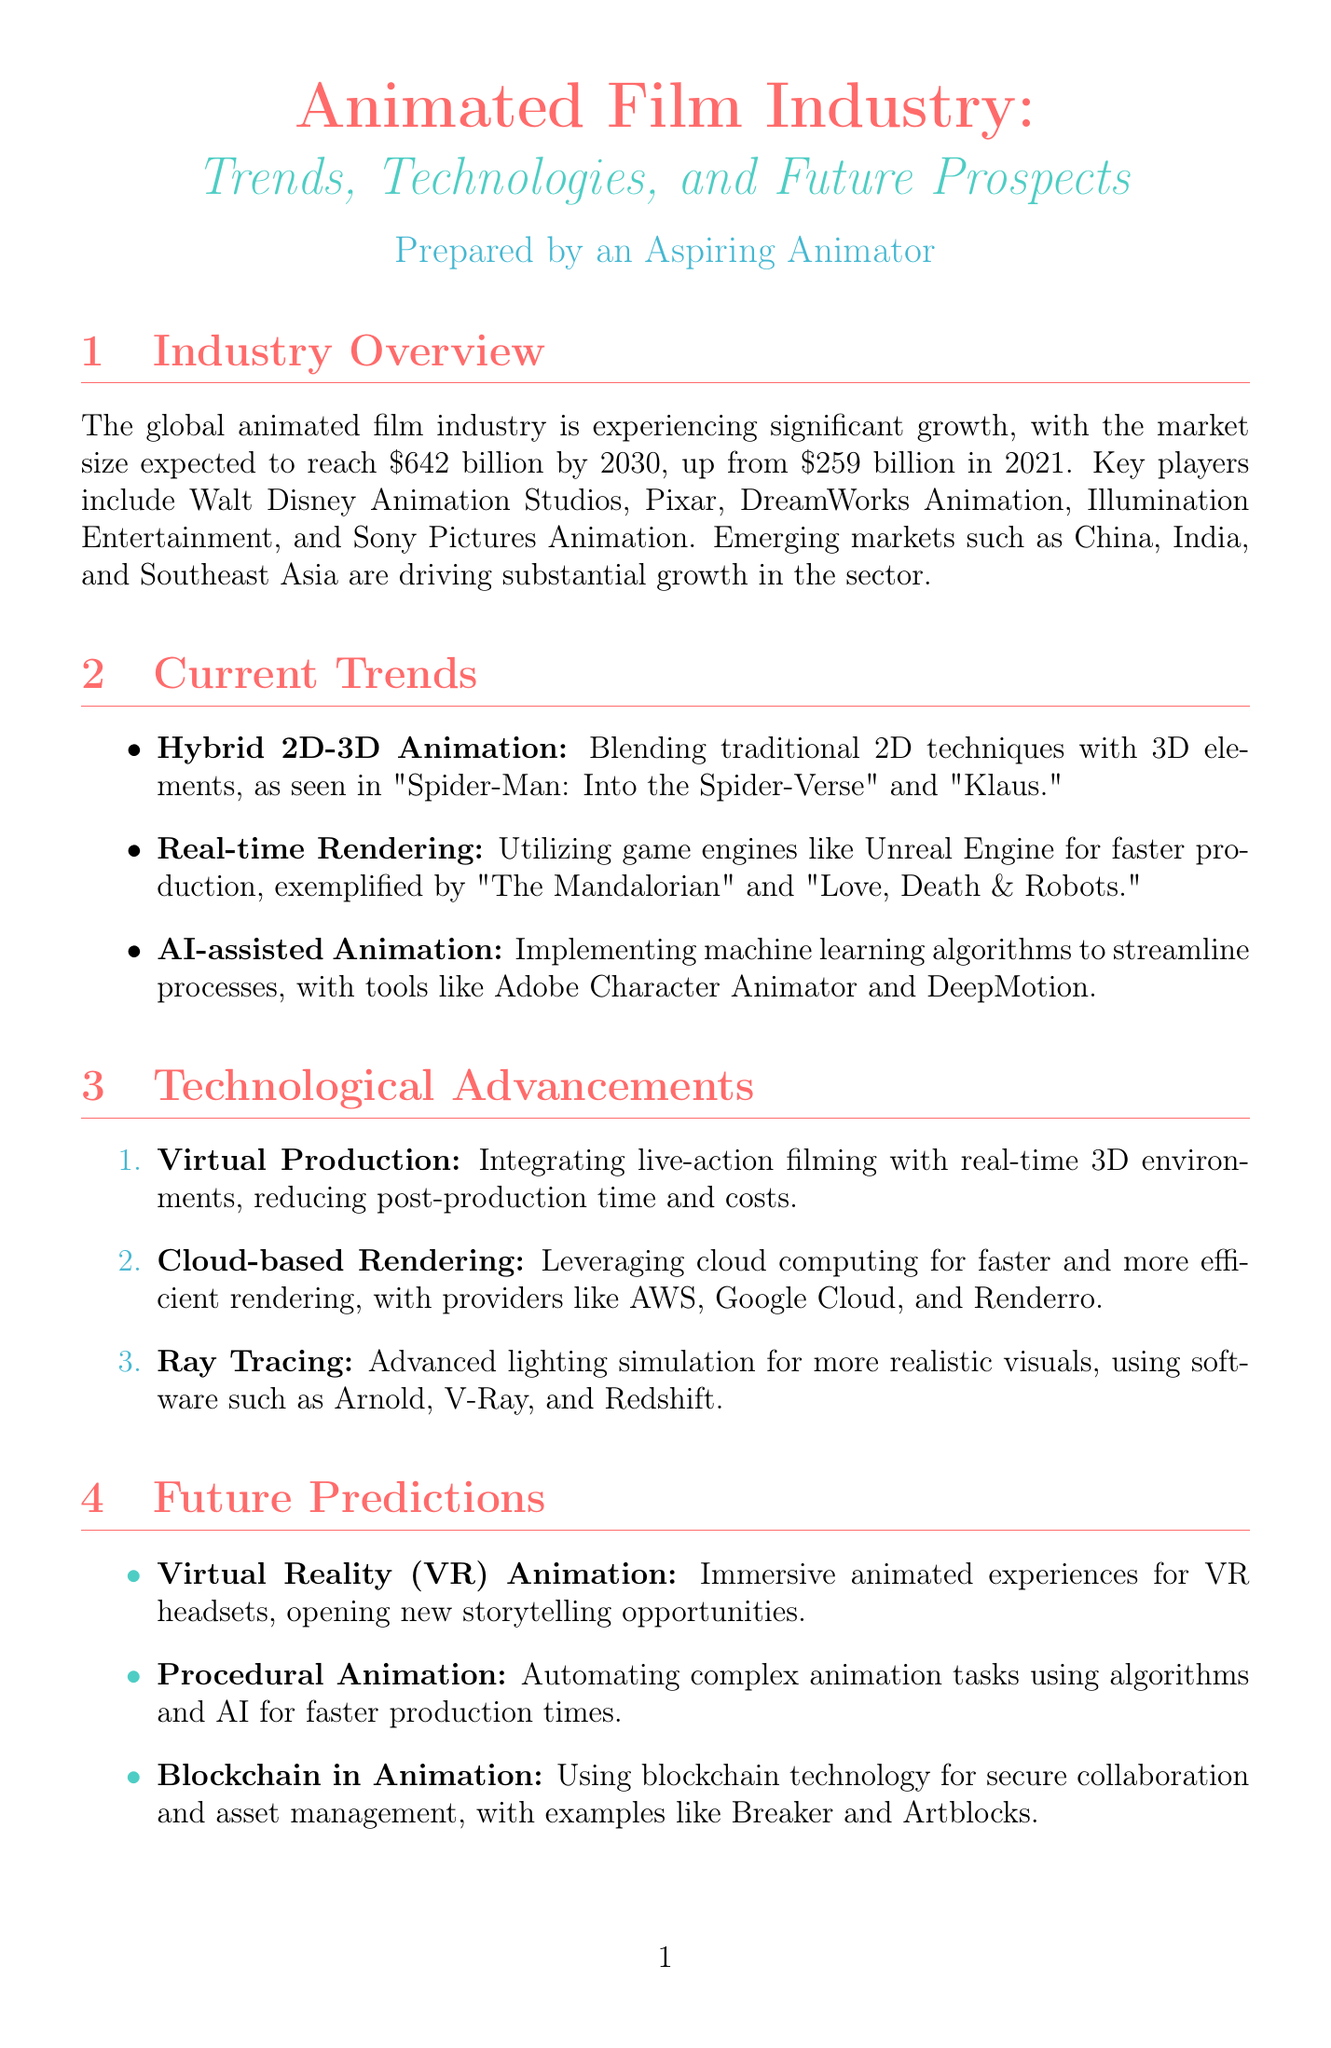What is the global market size for animated films in 2021? The document states the global market size for animated films was $259 billion in 2021.
Answer: $259 billion Which company is listed as a key player in the animated film industry? The report mentions key players, one of which is Walt Disney Animation Studios.
Answer: Walt Disney Animation Studios What is an example of a film using hybrid 2D-3D animation? The document provides "Spider-Man: Into the Spider-Verse" as an example of hybrid 2D-3D animation.
Answer: Spider-Man: Into the Spider-Verse What is the predicted market size for the animated film industry by 2030? The document predicts the market size to reach $642 billion by 2030.
Answer: $642 billion What technology integrates live-action filming with 3D environments? The document describes Virtual Production as the technology that integrates live-action filming with 3D environments.
Answer: Virtual Production Which software is known for its user-friendly interface according to the software comparison? The document notes Cinema 4D for its user-friendly interface.
Answer: Cinema 4D What is one benefit of procedural animation? The report states that one benefit of procedural animation is faster production times.
Answer: Faster production times When is the SIGGRAPH 2023 event scheduled? The document indicates that SIGGRAPH 2023 is scheduled for August 6-10, 2023.
Answer: August 6-10, 2023 What type of learning resource is Animation Mentor? The document classifies Animation Mentor as an online school focused on character animation.
Answer: Online school 